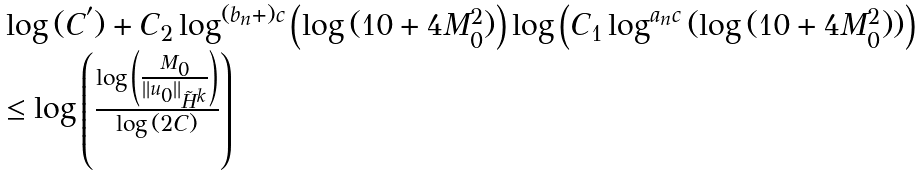Convert formula to latex. <formula><loc_0><loc_0><loc_500><loc_500>\begin{array} { l } \log { ( C ^ { ^ { \prime } } ) } + C _ { 2 } \log ^ { ( b _ { n } + ) c } \left ( \log { ( 1 0 + 4 M ^ { 2 } _ { 0 } ) } \right ) \log { \left ( C _ { 1 } \log ^ { a _ { n } c } { ( \log { ( 1 0 + 4 M _ { 0 } ^ { 2 } ) } ) } \right ) } \\ \leq \log { \left ( \frac { \log { \left ( \frac { M _ { 0 } } { \| u _ { 0 } \| _ { \tilde { H } ^ { k } } } \right ) } } { \log { ( 2 C ) } } \right ) } \end{array}</formula> 